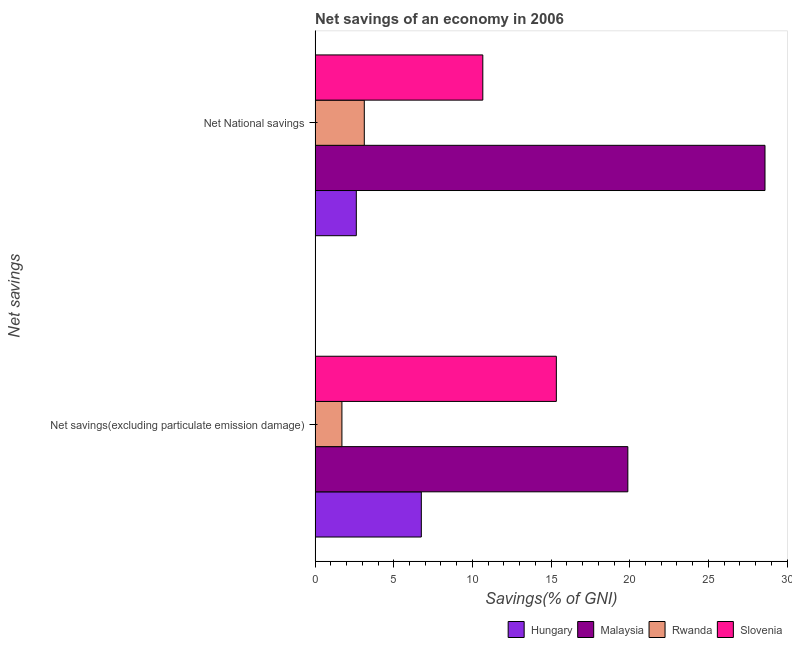How many different coloured bars are there?
Make the answer very short. 4. How many groups of bars are there?
Make the answer very short. 2. How many bars are there on the 1st tick from the top?
Provide a short and direct response. 4. What is the label of the 2nd group of bars from the top?
Keep it short and to the point. Net savings(excluding particulate emission damage). What is the net savings(excluding particulate emission damage) in Slovenia?
Your answer should be very brief. 15.33. Across all countries, what is the maximum net savings(excluding particulate emission damage)?
Provide a short and direct response. 19.88. Across all countries, what is the minimum net savings(excluding particulate emission damage)?
Make the answer very short. 1.7. In which country was the net savings(excluding particulate emission damage) maximum?
Give a very brief answer. Malaysia. In which country was the net savings(excluding particulate emission damage) minimum?
Your answer should be compact. Rwanda. What is the total net savings(excluding particulate emission damage) in the graph?
Offer a very short reply. 43.67. What is the difference between the net savings(excluding particulate emission damage) in Rwanda and that in Malaysia?
Your answer should be compact. -18.17. What is the difference between the net savings(excluding particulate emission damage) in Slovenia and the net national savings in Malaysia?
Offer a terse response. -13.26. What is the average net national savings per country?
Make the answer very short. 11.25. What is the difference between the net savings(excluding particulate emission damage) and net national savings in Rwanda?
Make the answer very short. -1.42. In how many countries, is the net national savings greater than 15 %?
Offer a terse response. 1. What is the ratio of the net savings(excluding particulate emission damage) in Rwanda to that in Malaysia?
Offer a terse response. 0.09. Is the net national savings in Rwanda less than that in Hungary?
Offer a terse response. No. What does the 4th bar from the top in Net National savings represents?
Ensure brevity in your answer.  Hungary. What does the 2nd bar from the bottom in Net National savings represents?
Your response must be concise. Malaysia. How many bars are there?
Provide a succinct answer. 8. How many countries are there in the graph?
Make the answer very short. 4. What is the difference between two consecutive major ticks on the X-axis?
Your answer should be compact. 5. Does the graph contain any zero values?
Provide a succinct answer. No. Where does the legend appear in the graph?
Offer a very short reply. Bottom right. What is the title of the graph?
Ensure brevity in your answer.  Net savings of an economy in 2006. What is the label or title of the X-axis?
Make the answer very short. Savings(% of GNI). What is the label or title of the Y-axis?
Your answer should be compact. Net savings. What is the Savings(% of GNI) in Hungary in Net savings(excluding particulate emission damage)?
Your response must be concise. 6.75. What is the Savings(% of GNI) of Malaysia in Net savings(excluding particulate emission damage)?
Offer a terse response. 19.88. What is the Savings(% of GNI) of Rwanda in Net savings(excluding particulate emission damage)?
Offer a very short reply. 1.7. What is the Savings(% of GNI) in Slovenia in Net savings(excluding particulate emission damage)?
Give a very brief answer. 15.33. What is the Savings(% of GNI) of Hungary in Net National savings?
Offer a terse response. 2.62. What is the Savings(% of GNI) of Malaysia in Net National savings?
Offer a terse response. 28.6. What is the Savings(% of GNI) in Rwanda in Net National savings?
Your answer should be compact. 3.13. What is the Savings(% of GNI) of Slovenia in Net National savings?
Your response must be concise. 10.66. Across all Net savings, what is the maximum Savings(% of GNI) of Hungary?
Make the answer very short. 6.75. Across all Net savings, what is the maximum Savings(% of GNI) of Malaysia?
Keep it short and to the point. 28.6. Across all Net savings, what is the maximum Savings(% of GNI) of Rwanda?
Give a very brief answer. 3.13. Across all Net savings, what is the maximum Savings(% of GNI) in Slovenia?
Your response must be concise. 15.33. Across all Net savings, what is the minimum Savings(% of GNI) of Hungary?
Your answer should be very brief. 2.62. Across all Net savings, what is the minimum Savings(% of GNI) in Malaysia?
Make the answer very short. 19.88. Across all Net savings, what is the minimum Savings(% of GNI) of Rwanda?
Provide a short and direct response. 1.7. Across all Net savings, what is the minimum Savings(% of GNI) in Slovenia?
Provide a succinct answer. 10.66. What is the total Savings(% of GNI) in Hungary in the graph?
Provide a short and direct response. 9.37. What is the total Savings(% of GNI) in Malaysia in the graph?
Your answer should be compact. 48.47. What is the total Savings(% of GNI) in Rwanda in the graph?
Provide a succinct answer. 4.83. What is the total Savings(% of GNI) in Slovenia in the graph?
Keep it short and to the point. 25.99. What is the difference between the Savings(% of GNI) in Hungary in Net savings(excluding particulate emission damage) and that in Net National savings?
Offer a terse response. 4.13. What is the difference between the Savings(% of GNI) of Malaysia in Net savings(excluding particulate emission damage) and that in Net National savings?
Your response must be concise. -8.72. What is the difference between the Savings(% of GNI) in Rwanda in Net savings(excluding particulate emission damage) and that in Net National savings?
Your response must be concise. -1.42. What is the difference between the Savings(% of GNI) in Slovenia in Net savings(excluding particulate emission damage) and that in Net National savings?
Provide a short and direct response. 4.67. What is the difference between the Savings(% of GNI) in Hungary in Net savings(excluding particulate emission damage) and the Savings(% of GNI) in Malaysia in Net National savings?
Ensure brevity in your answer.  -21.84. What is the difference between the Savings(% of GNI) in Hungary in Net savings(excluding particulate emission damage) and the Savings(% of GNI) in Rwanda in Net National savings?
Make the answer very short. 3.63. What is the difference between the Savings(% of GNI) in Hungary in Net savings(excluding particulate emission damage) and the Savings(% of GNI) in Slovenia in Net National savings?
Give a very brief answer. -3.91. What is the difference between the Savings(% of GNI) of Malaysia in Net savings(excluding particulate emission damage) and the Savings(% of GNI) of Rwanda in Net National savings?
Your response must be concise. 16.75. What is the difference between the Savings(% of GNI) of Malaysia in Net savings(excluding particulate emission damage) and the Savings(% of GNI) of Slovenia in Net National savings?
Your answer should be very brief. 9.22. What is the difference between the Savings(% of GNI) in Rwanda in Net savings(excluding particulate emission damage) and the Savings(% of GNI) in Slovenia in Net National savings?
Offer a terse response. -8.96. What is the average Savings(% of GNI) in Hungary per Net savings?
Keep it short and to the point. 4.69. What is the average Savings(% of GNI) in Malaysia per Net savings?
Your answer should be very brief. 24.24. What is the average Savings(% of GNI) of Rwanda per Net savings?
Make the answer very short. 2.42. What is the average Savings(% of GNI) in Slovenia per Net savings?
Offer a terse response. 13. What is the difference between the Savings(% of GNI) in Hungary and Savings(% of GNI) in Malaysia in Net savings(excluding particulate emission damage)?
Provide a succinct answer. -13.13. What is the difference between the Savings(% of GNI) in Hungary and Savings(% of GNI) in Rwanda in Net savings(excluding particulate emission damage)?
Keep it short and to the point. 5.05. What is the difference between the Savings(% of GNI) of Hungary and Savings(% of GNI) of Slovenia in Net savings(excluding particulate emission damage)?
Your response must be concise. -8.58. What is the difference between the Savings(% of GNI) of Malaysia and Savings(% of GNI) of Rwanda in Net savings(excluding particulate emission damage)?
Provide a short and direct response. 18.17. What is the difference between the Savings(% of GNI) of Malaysia and Savings(% of GNI) of Slovenia in Net savings(excluding particulate emission damage)?
Offer a very short reply. 4.54. What is the difference between the Savings(% of GNI) in Rwanda and Savings(% of GNI) in Slovenia in Net savings(excluding particulate emission damage)?
Your response must be concise. -13.63. What is the difference between the Savings(% of GNI) of Hungary and Savings(% of GNI) of Malaysia in Net National savings?
Keep it short and to the point. -25.98. What is the difference between the Savings(% of GNI) of Hungary and Savings(% of GNI) of Rwanda in Net National savings?
Your response must be concise. -0.51. What is the difference between the Savings(% of GNI) of Hungary and Savings(% of GNI) of Slovenia in Net National savings?
Provide a succinct answer. -8.04. What is the difference between the Savings(% of GNI) in Malaysia and Savings(% of GNI) in Rwanda in Net National savings?
Ensure brevity in your answer.  25.47. What is the difference between the Savings(% of GNI) in Malaysia and Savings(% of GNI) in Slovenia in Net National savings?
Make the answer very short. 17.94. What is the difference between the Savings(% of GNI) in Rwanda and Savings(% of GNI) in Slovenia in Net National savings?
Provide a short and direct response. -7.53. What is the ratio of the Savings(% of GNI) in Hungary in Net savings(excluding particulate emission damage) to that in Net National savings?
Your answer should be compact. 2.58. What is the ratio of the Savings(% of GNI) in Malaysia in Net savings(excluding particulate emission damage) to that in Net National savings?
Make the answer very short. 0.7. What is the ratio of the Savings(% of GNI) in Rwanda in Net savings(excluding particulate emission damage) to that in Net National savings?
Keep it short and to the point. 0.55. What is the ratio of the Savings(% of GNI) in Slovenia in Net savings(excluding particulate emission damage) to that in Net National savings?
Your response must be concise. 1.44. What is the difference between the highest and the second highest Savings(% of GNI) in Hungary?
Your answer should be very brief. 4.13. What is the difference between the highest and the second highest Savings(% of GNI) in Malaysia?
Offer a terse response. 8.72. What is the difference between the highest and the second highest Savings(% of GNI) in Rwanda?
Make the answer very short. 1.42. What is the difference between the highest and the second highest Savings(% of GNI) of Slovenia?
Offer a terse response. 4.67. What is the difference between the highest and the lowest Savings(% of GNI) of Hungary?
Provide a succinct answer. 4.13. What is the difference between the highest and the lowest Savings(% of GNI) in Malaysia?
Make the answer very short. 8.72. What is the difference between the highest and the lowest Savings(% of GNI) in Rwanda?
Your response must be concise. 1.42. What is the difference between the highest and the lowest Savings(% of GNI) of Slovenia?
Make the answer very short. 4.67. 